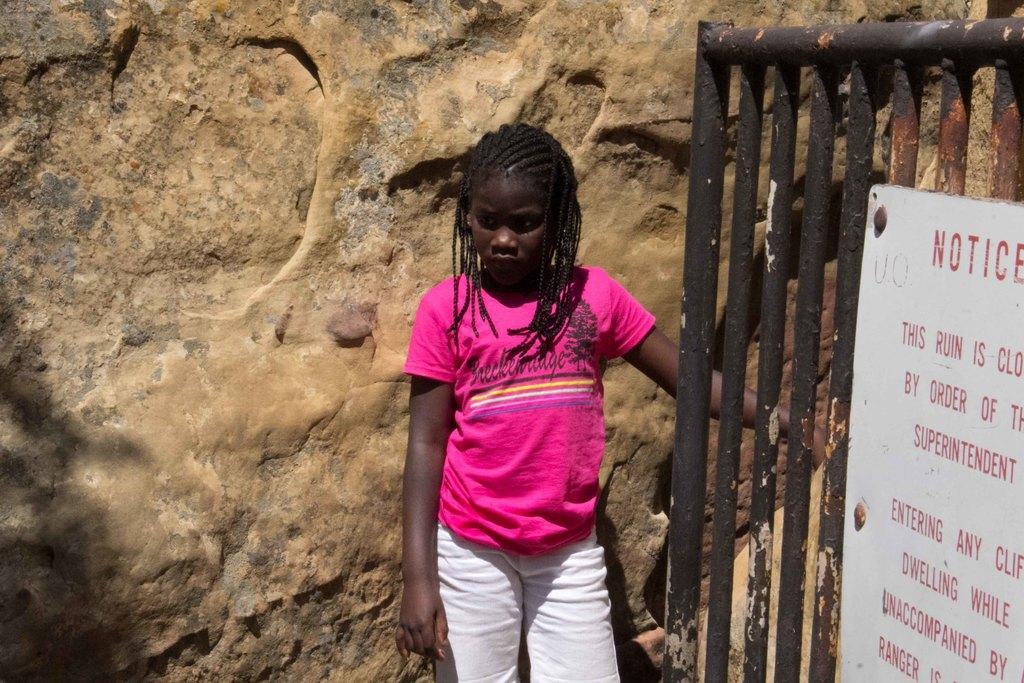In one or two sentences, can you explain what this image depicts? In this picture there is a girl standing, behind her we can see wall and we can see board and rods. 